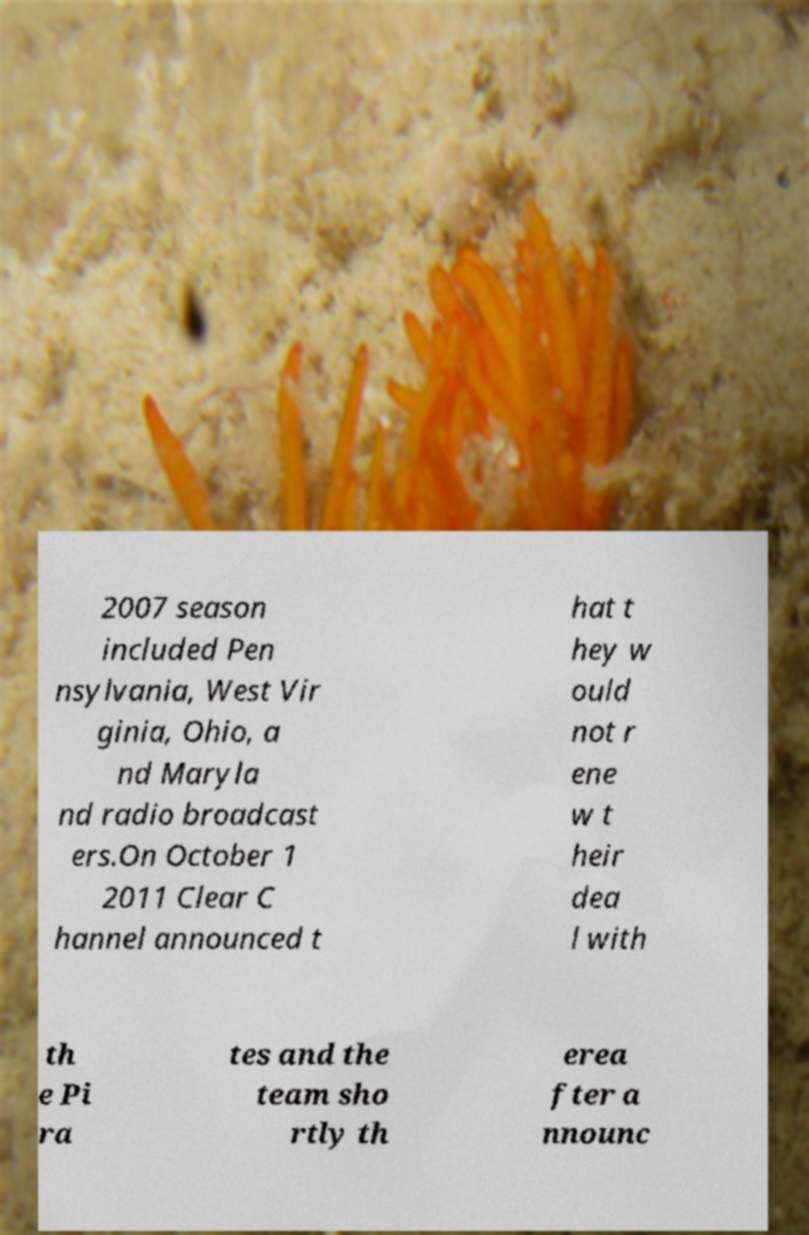Can you read and provide the text displayed in the image?This photo seems to have some interesting text. Can you extract and type it out for me? 2007 season included Pen nsylvania, West Vir ginia, Ohio, a nd Maryla nd radio broadcast ers.On October 1 2011 Clear C hannel announced t hat t hey w ould not r ene w t heir dea l with th e Pi ra tes and the team sho rtly th erea fter a nnounc 